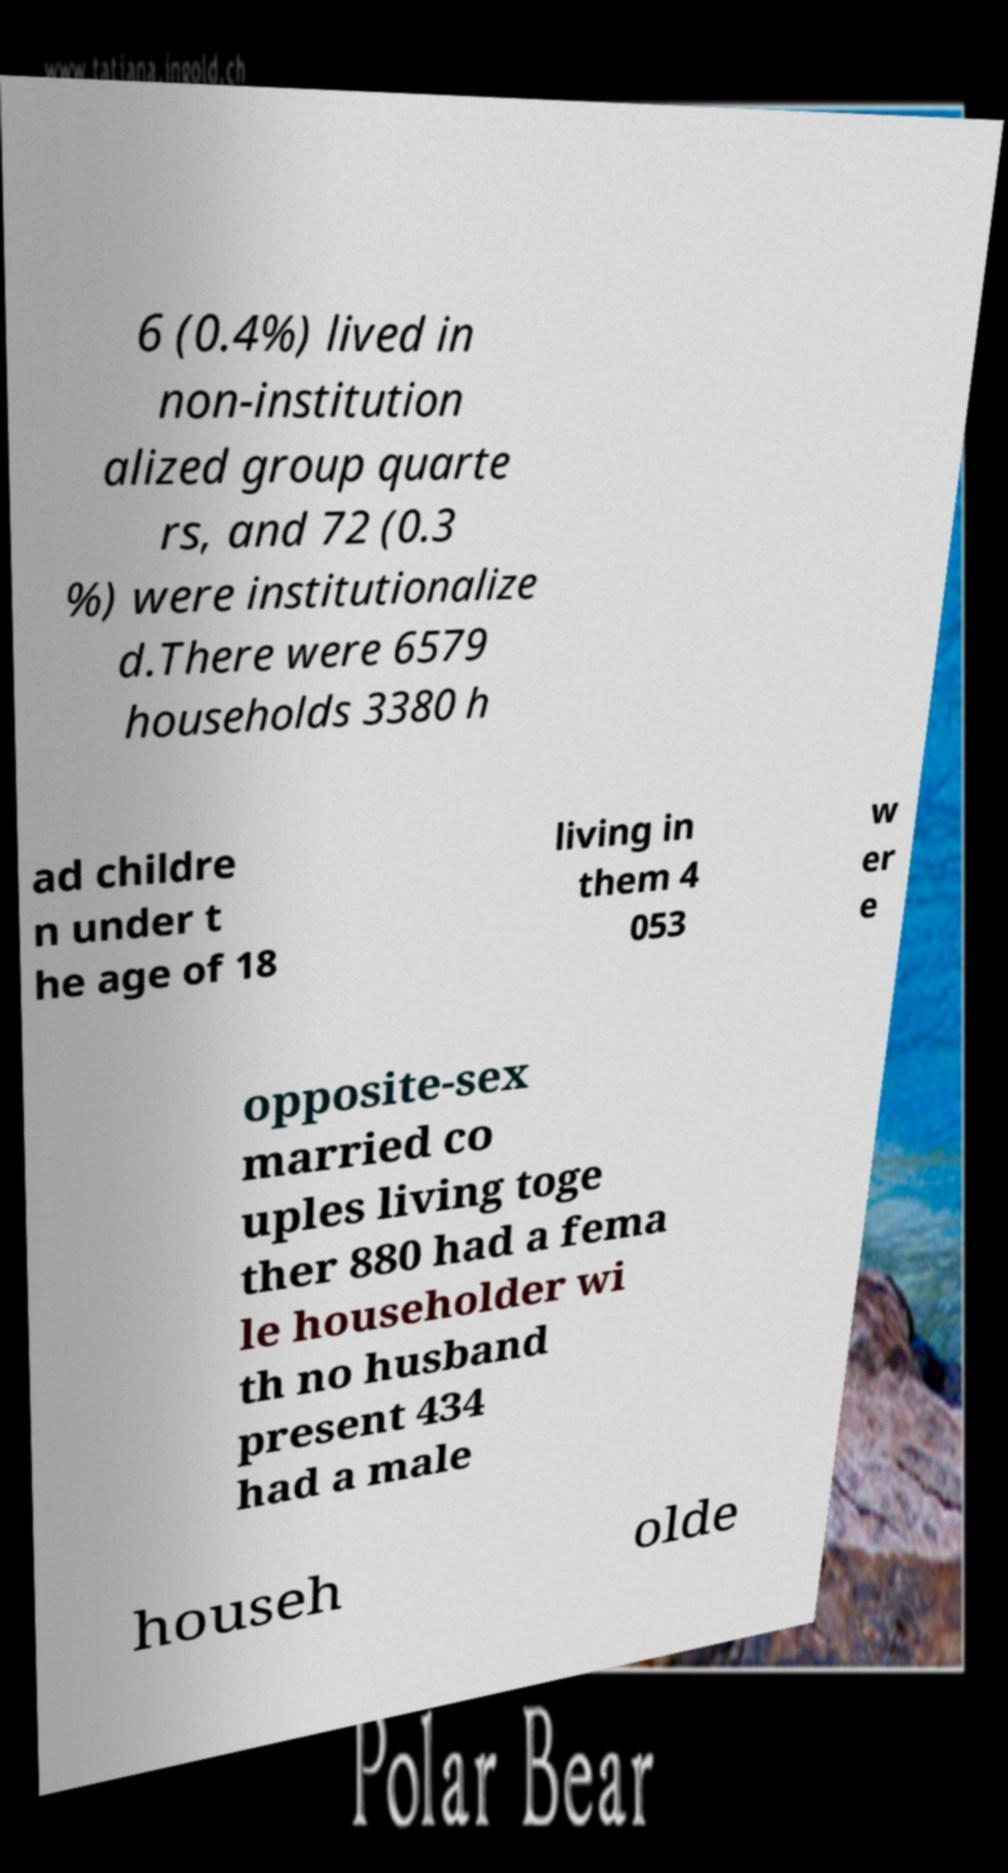Please identify and transcribe the text found in this image. 6 (0.4%) lived in non-institution alized group quarte rs, and 72 (0.3 %) were institutionalize d.There were 6579 households 3380 h ad childre n under t he age of 18 living in them 4 053 w er e opposite-sex married co uples living toge ther 880 had a fema le householder wi th no husband present 434 had a male househ olde 